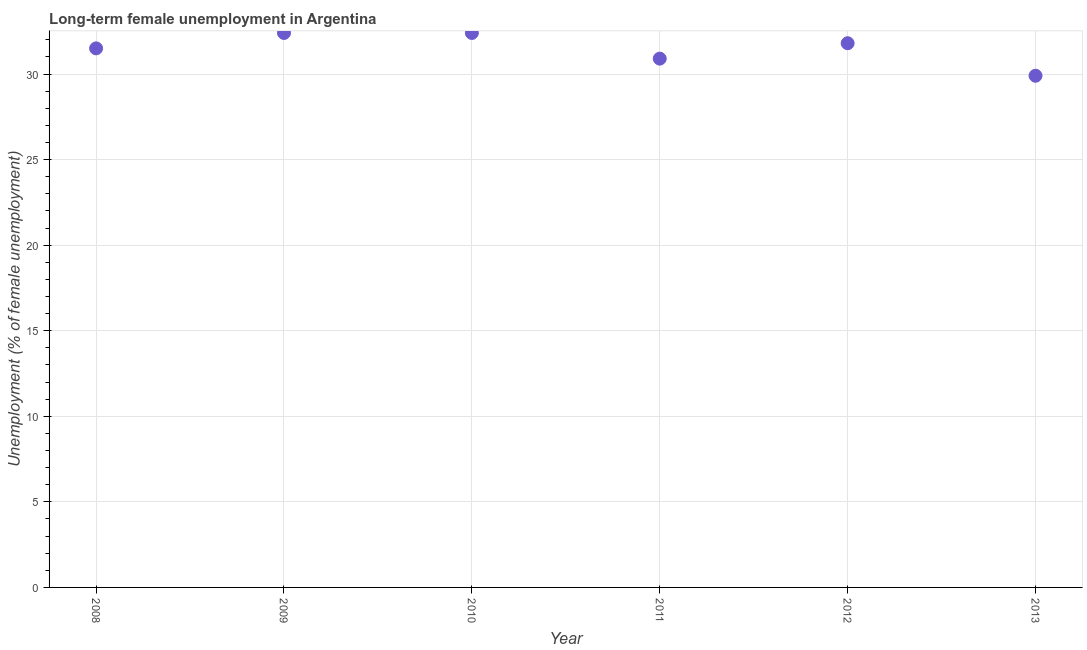What is the long-term female unemployment in 2011?
Provide a succinct answer. 30.9. Across all years, what is the maximum long-term female unemployment?
Offer a terse response. 32.4. Across all years, what is the minimum long-term female unemployment?
Make the answer very short. 29.9. In which year was the long-term female unemployment maximum?
Your answer should be very brief. 2009. In which year was the long-term female unemployment minimum?
Offer a terse response. 2013. What is the sum of the long-term female unemployment?
Ensure brevity in your answer.  188.9. What is the difference between the long-term female unemployment in 2008 and 2011?
Offer a very short reply. 0.6. What is the average long-term female unemployment per year?
Your answer should be compact. 31.48. What is the median long-term female unemployment?
Your answer should be compact. 31.65. In how many years, is the long-term female unemployment greater than 5 %?
Offer a very short reply. 6. What is the ratio of the long-term female unemployment in 2008 to that in 2011?
Offer a very short reply. 1.02. Is the difference between the long-term female unemployment in 2011 and 2013 greater than the difference between any two years?
Ensure brevity in your answer.  No. Is the sum of the long-term female unemployment in 2008 and 2010 greater than the maximum long-term female unemployment across all years?
Provide a short and direct response. Yes. What is the difference between the highest and the lowest long-term female unemployment?
Your answer should be compact. 2.5. In how many years, is the long-term female unemployment greater than the average long-term female unemployment taken over all years?
Offer a terse response. 4. What is the difference between two consecutive major ticks on the Y-axis?
Give a very brief answer. 5. What is the title of the graph?
Make the answer very short. Long-term female unemployment in Argentina. What is the label or title of the Y-axis?
Provide a succinct answer. Unemployment (% of female unemployment). What is the Unemployment (% of female unemployment) in 2008?
Make the answer very short. 31.5. What is the Unemployment (% of female unemployment) in 2009?
Keep it short and to the point. 32.4. What is the Unemployment (% of female unemployment) in 2010?
Keep it short and to the point. 32.4. What is the Unemployment (% of female unemployment) in 2011?
Your answer should be very brief. 30.9. What is the Unemployment (% of female unemployment) in 2012?
Provide a short and direct response. 31.8. What is the Unemployment (% of female unemployment) in 2013?
Ensure brevity in your answer.  29.9. What is the difference between the Unemployment (% of female unemployment) in 2008 and 2011?
Provide a succinct answer. 0.6. What is the difference between the Unemployment (% of female unemployment) in 2008 and 2013?
Your answer should be very brief. 1.6. What is the difference between the Unemployment (% of female unemployment) in 2009 and 2012?
Your answer should be compact. 0.6. What is the difference between the Unemployment (% of female unemployment) in 2010 and 2011?
Your answer should be very brief. 1.5. What is the difference between the Unemployment (% of female unemployment) in 2011 and 2012?
Your answer should be compact. -0.9. What is the difference between the Unemployment (% of female unemployment) in 2012 and 2013?
Your answer should be very brief. 1.9. What is the ratio of the Unemployment (% of female unemployment) in 2008 to that in 2010?
Your answer should be very brief. 0.97. What is the ratio of the Unemployment (% of female unemployment) in 2008 to that in 2012?
Make the answer very short. 0.99. What is the ratio of the Unemployment (% of female unemployment) in 2008 to that in 2013?
Give a very brief answer. 1.05. What is the ratio of the Unemployment (% of female unemployment) in 2009 to that in 2010?
Keep it short and to the point. 1. What is the ratio of the Unemployment (% of female unemployment) in 2009 to that in 2011?
Give a very brief answer. 1.05. What is the ratio of the Unemployment (% of female unemployment) in 2009 to that in 2012?
Make the answer very short. 1.02. What is the ratio of the Unemployment (% of female unemployment) in 2009 to that in 2013?
Give a very brief answer. 1.08. What is the ratio of the Unemployment (% of female unemployment) in 2010 to that in 2011?
Make the answer very short. 1.05. What is the ratio of the Unemployment (% of female unemployment) in 2010 to that in 2012?
Make the answer very short. 1.02. What is the ratio of the Unemployment (% of female unemployment) in 2010 to that in 2013?
Offer a very short reply. 1.08. What is the ratio of the Unemployment (% of female unemployment) in 2011 to that in 2013?
Keep it short and to the point. 1.03. What is the ratio of the Unemployment (% of female unemployment) in 2012 to that in 2013?
Ensure brevity in your answer.  1.06. 